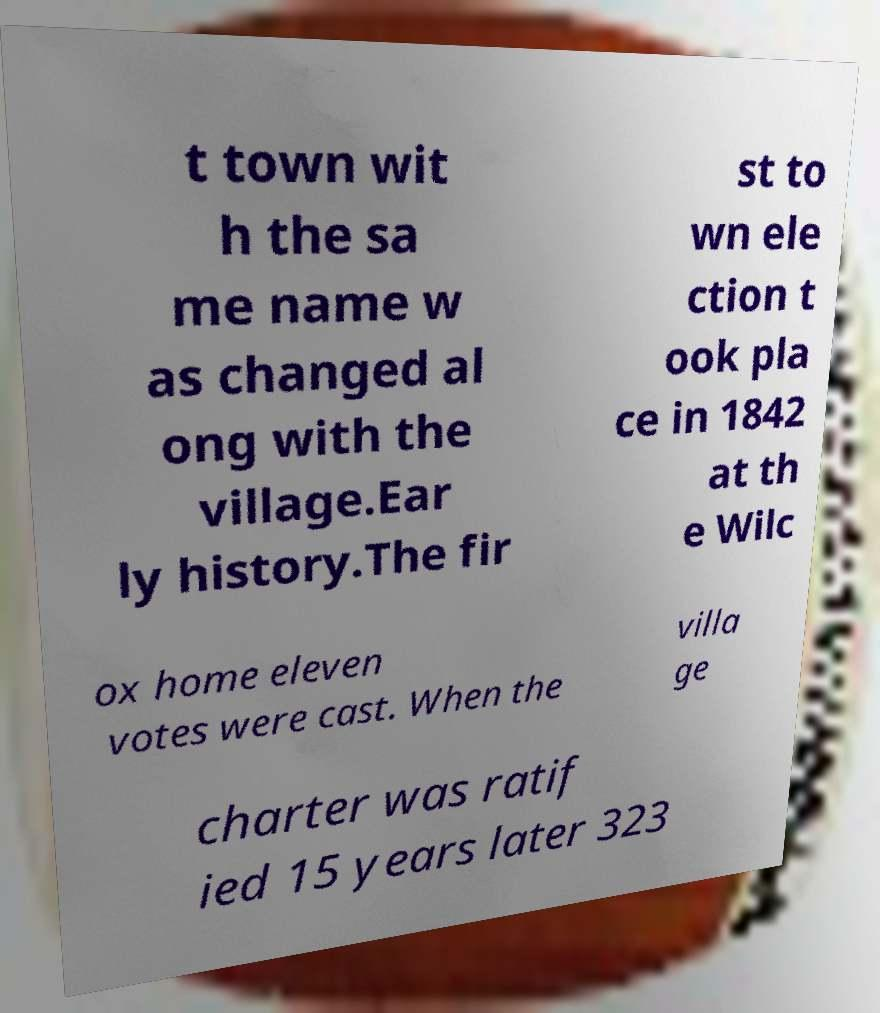There's text embedded in this image that I need extracted. Can you transcribe it verbatim? t town wit h the sa me name w as changed al ong with the village.Ear ly history.The fir st to wn ele ction t ook pla ce in 1842 at th e Wilc ox home eleven votes were cast. When the villa ge charter was ratif ied 15 years later 323 